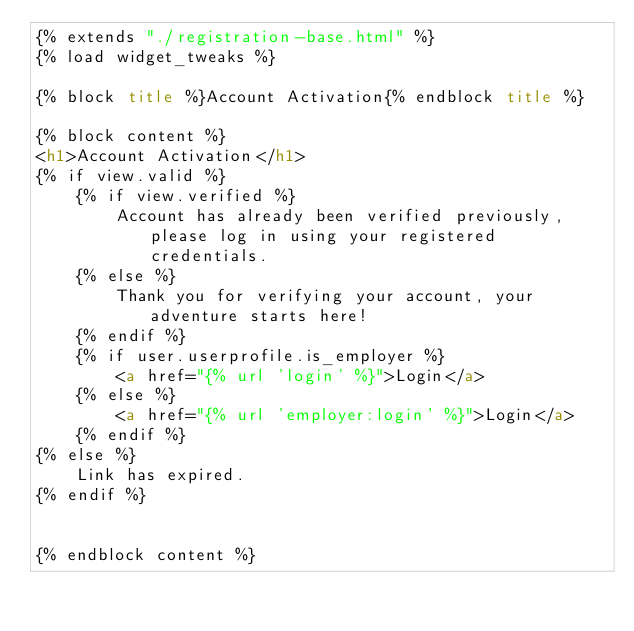<code> <loc_0><loc_0><loc_500><loc_500><_HTML_>{% extends "./registration-base.html" %}
{% load widget_tweaks %}

{% block title %}Account Activation{% endblock title %}

{% block content %}
<h1>Account Activation</h1>
{% if view.valid %}
    {% if view.verified %}
        Account has already been verified previously, please log in using your registered credentials.
    {% else %}
        Thank you for verifying your account, your adventure starts here!
    {% endif %}
    {% if user.userprofile.is_employer %}
        <a href="{% url 'login' %}">Login</a>
    {% else %}
        <a href="{% url 'employer:login' %}">Login</a>
    {% endif %}
{% else %}
    Link has expired.
{% endif %}


{% endblock content %}</code> 